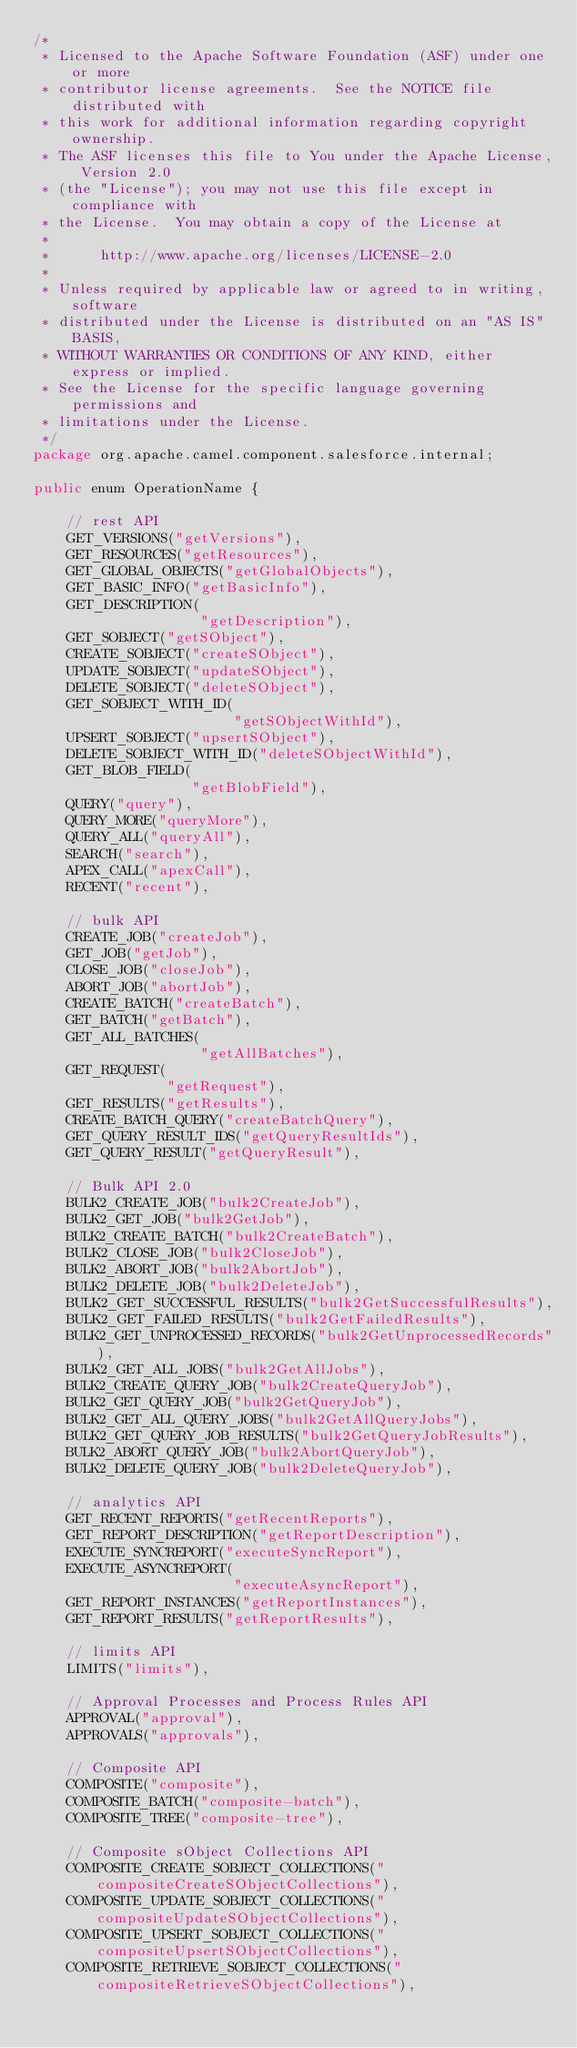<code> <loc_0><loc_0><loc_500><loc_500><_Java_>/*
 * Licensed to the Apache Software Foundation (ASF) under one or more
 * contributor license agreements.  See the NOTICE file distributed with
 * this work for additional information regarding copyright ownership.
 * The ASF licenses this file to You under the Apache License, Version 2.0
 * (the "License"); you may not use this file except in compliance with
 * the License.  You may obtain a copy of the License at
 *
 *      http://www.apache.org/licenses/LICENSE-2.0
 *
 * Unless required by applicable law or agreed to in writing, software
 * distributed under the License is distributed on an "AS IS" BASIS,
 * WITHOUT WARRANTIES OR CONDITIONS OF ANY KIND, either express or implied.
 * See the License for the specific language governing permissions and
 * limitations under the License.
 */
package org.apache.camel.component.salesforce.internal;

public enum OperationName {

    // rest API
    GET_VERSIONS("getVersions"),
    GET_RESOURCES("getResources"),
    GET_GLOBAL_OBJECTS("getGlobalObjects"),
    GET_BASIC_INFO("getBasicInfo"),
    GET_DESCRIPTION(
                    "getDescription"),
    GET_SOBJECT("getSObject"),
    CREATE_SOBJECT("createSObject"),
    UPDATE_SOBJECT("updateSObject"),
    DELETE_SOBJECT("deleteSObject"),
    GET_SOBJECT_WITH_ID(
                        "getSObjectWithId"),
    UPSERT_SOBJECT("upsertSObject"),
    DELETE_SOBJECT_WITH_ID("deleteSObjectWithId"),
    GET_BLOB_FIELD(
                   "getBlobField"),
    QUERY("query"),
    QUERY_MORE("queryMore"),
    QUERY_ALL("queryAll"),
    SEARCH("search"),
    APEX_CALL("apexCall"),
    RECENT("recent"),

    // bulk API
    CREATE_JOB("createJob"),
    GET_JOB("getJob"),
    CLOSE_JOB("closeJob"),
    ABORT_JOB("abortJob"),
    CREATE_BATCH("createBatch"),
    GET_BATCH("getBatch"),
    GET_ALL_BATCHES(
                    "getAllBatches"),
    GET_REQUEST(
                "getRequest"),
    GET_RESULTS("getResults"),
    CREATE_BATCH_QUERY("createBatchQuery"),
    GET_QUERY_RESULT_IDS("getQueryResultIds"),
    GET_QUERY_RESULT("getQueryResult"),

    // Bulk API 2.0
    BULK2_CREATE_JOB("bulk2CreateJob"),
    BULK2_GET_JOB("bulk2GetJob"),
    BULK2_CREATE_BATCH("bulk2CreateBatch"),
    BULK2_CLOSE_JOB("bulk2CloseJob"),
    BULK2_ABORT_JOB("bulk2AbortJob"),
    BULK2_DELETE_JOB("bulk2DeleteJob"),
    BULK2_GET_SUCCESSFUL_RESULTS("bulk2GetSuccessfulResults"),
    BULK2_GET_FAILED_RESULTS("bulk2GetFailedResults"),
    BULK2_GET_UNPROCESSED_RECORDS("bulk2GetUnprocessedRecords"),
    BULK2_GET_ALL_JOBS("bulk2GetAllJobs"),
    BULK2_CREATE_QUERY_JOB("bulk2CreateQueryJob"),
    BULK2_GET_QUERY_JOB("bulk2GetQueryJob"),
    BULK2_GET_ALL_QUERY_JOBS("bulk2GetAllQueryJobs"),
    BULK2_GET_QUERY_JOB_RESULTS("bulk2GetQueryJobResults"),
    BULK2_ABORT_QUERY_JOB("bulk2AbortQueryJob"),
    BULK2_DELETE_QUERY_JOB("bulk2DeleteQueryJob"),

    // analytics API
    GET_RECENT_REPORTS("getRecentReports"),
    GET_REPORT_DESCRIPTION("getReportDescription"),
    EXECUTE_SYNCREPORT("executeSyncReport"),
    EXECUTE_ASYNCREPORT(
                        "executeAsyncReport"),
    GET_REPORT_INSTANCES("getReportInstances"),
    GET_REPORT_RESULTS("getReportResults"),

    // limits API
    LIMITS("limits"),

    // Approval Processes and Process Rules API
    APPROVAL("approval"),
    APPROVALS("approvals"),

    // Composite API
    COMPOSITE("composite"),
    COMPOSITE_BATCH("composite-batch"),
    COMPOSITE_TREE("composite-tree"),

    // Composite sObject Collections API
    COMPOSITE_CREATE_SOBJECT_COLLECTIONS("compositeCreateSObjectCollections"),
    COMPOSITE_UPDATE_SOBJECT_COLLECTIONS("compositeUpdateSObjectCollections"),
    COMPOSITE_UPSERT_SOBJECT_COLLECTIONS("compositeUpsertSObjectCollections"),
    COMPOSITE_RETRIEVE_SOBJECT_COLLECTIONS("compositeRetrieveSObjectCollections"),</code> 